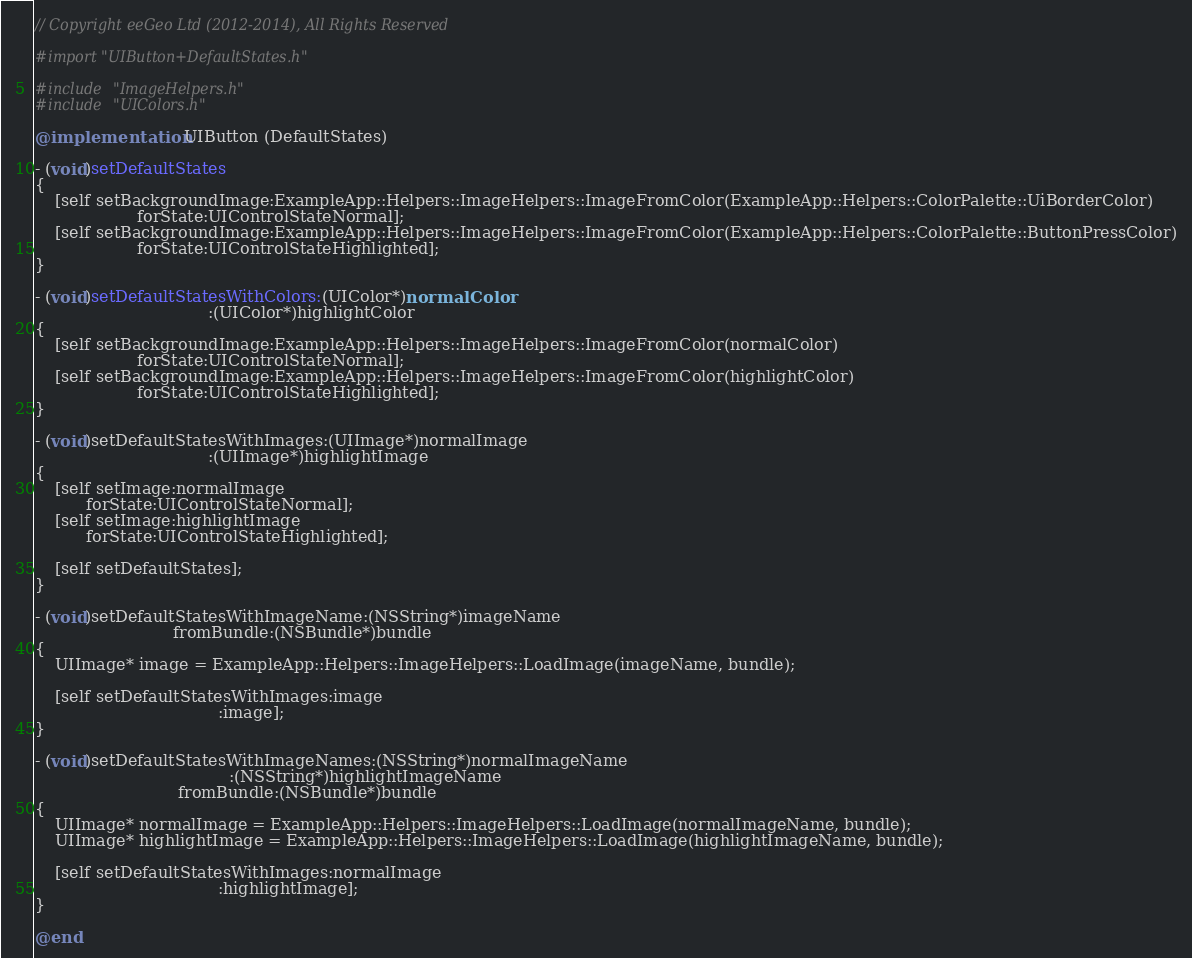<code> <loc_0><loc_0><loc_500><loc_500><_ObjectiveC_>// Copyright eeGeo Ltd (2012-2014), All Rights Reserved

#import "UIButton+DefaultStates.h"

#include "ImageHelpers.h"
#include "UIColors.h"

@implementation UIButton (DefaultStates)

- (void)setDefaultStates
{
    [self setBackgroundImage:ExampleApp::Helpers::ImageHelpers::ImageFromColor(ExampleApp::Helpers::ColorPalette::UiBorderColor)
                    forState:UIControlStateNormal];
    [self setBackgroundImage:ExampleApp::Helpers::ImageHelpers::ImageFromColor(ExampleApp::Helpers::ColorPalette::ButtonPressColor)
                    forState:UIControlStateHighlighted];
}

- (void)setDefaultStatesWithColors:(UIColor*)normalColor
                                  :(UIColor*)highlightColor
{
    [self setBackgroundImage:ExampleApp::Helpers::ImageHelpers::ImageFromColor(normalColor)
                    forState:UIControlStateNormal];
    [self setBackgroundImage:ExampleApp::Helpers::ImageHelpers::ImageFromColor(highlightColor)
                    forState:UIControlStateHighlighted];
}

- (void)setDefaultStatesWithImages:(UIImage*)normalImage
                                  :(UIImage*)highlightImage
{
    [self setImage:normalImage
          forState:UIControlStateNormal];
    [self setImage:highlightImage
          forState:UIControlStateHighlighted];
    
    [self setDefaultStates];
}

- (void)setDefaultStatesWithImageName:(NSString*)imageName
                           fromBundle:(NSBundle*)bundle
{
    UIImage* image = ExampleApp::Helpers::ImageHelpers::LoadImage(imageName, bundle);
    
    [self setDefaultStatesWithImages:image
                                    :image];
}

- (void)setDefaultStatesWithImageNames:(NSString*)normalImageName
                                      :(NSString*)highlightImageName
                            fromBundle:(NSBundle*)bundle
{
    UIImage* normalImage = ExampleApp::Helpers::ImageHelpers::LoadImage(normalImageName, bundle);
    UIImage* highlightImage = ExampleApp::Helpers::ImageHelpers::LoadImage(highlightImageName, bundle);
    
    [self setDefaultStatesWithImages:normalImage
                                    :highlightImage];
}

@end
</code> 